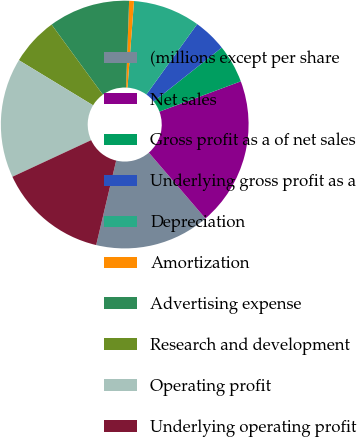Convert chart. <chart><loc_0><loc_0><loc_500><loc_500><pie_chart><fcel>(millions except per share<fcel>Net sales<fcel>Gross profit as a of net sales<fcel>Underlying gross profit as a<fcel>Depreciation<fcel>Amortization<fcel>Advertising expense<fcel>Research and development<fcel>Operating profit<fcel>Underlying operating profit<nl><fcel>15.0%<fcel>19.37%<fcel>5.0%<fcel>4.38%<fcel>8.75%<fcel>0.63%<fcel>10.62%<fcel>6.25%<fcel>15.62%<fcel>14.37%<nl></chart> 